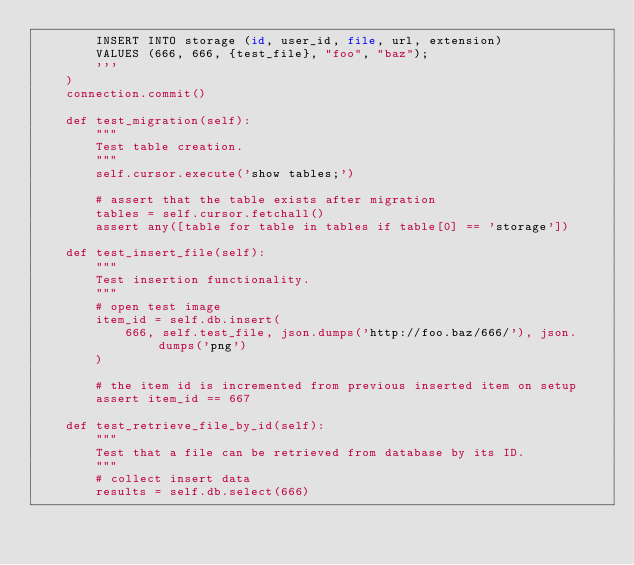Convert code to text. <code><loc_0><loc_0><loc_500><loc_500><_Python_>        INSERT INTO storage (id, user_id, file, url, extension)
        VALUES (666, 666, {test_file}, "foo", "baz");
        '''
    )
    connection.commit()

    def test_migration(self):
        """
        Test table creation.
        """
        self.cursor.execute('show tables;')

        # assert that the table exists after migration
        tables = self.cursor.fetchall()
        assert any([table for table in tables if table[0] == 'storage'])
        
    def test_insert_file(self):
        """
        Test insertion functionality.
        """
        # open test image
        item_id = self.db.insert(
            666, self.test_file, json.dumps('http://foo.baz/666/'), json.dumps('png')
        )

        # the item id is incremented from previous inserted item on setup
        assert item_id == 667

    def test_retrieve_file_by_id(self):
        """
        Test that a file can be retrieved from database by its ID.
        """
        # collect insert data
        results = self.db.select(666)</code> 